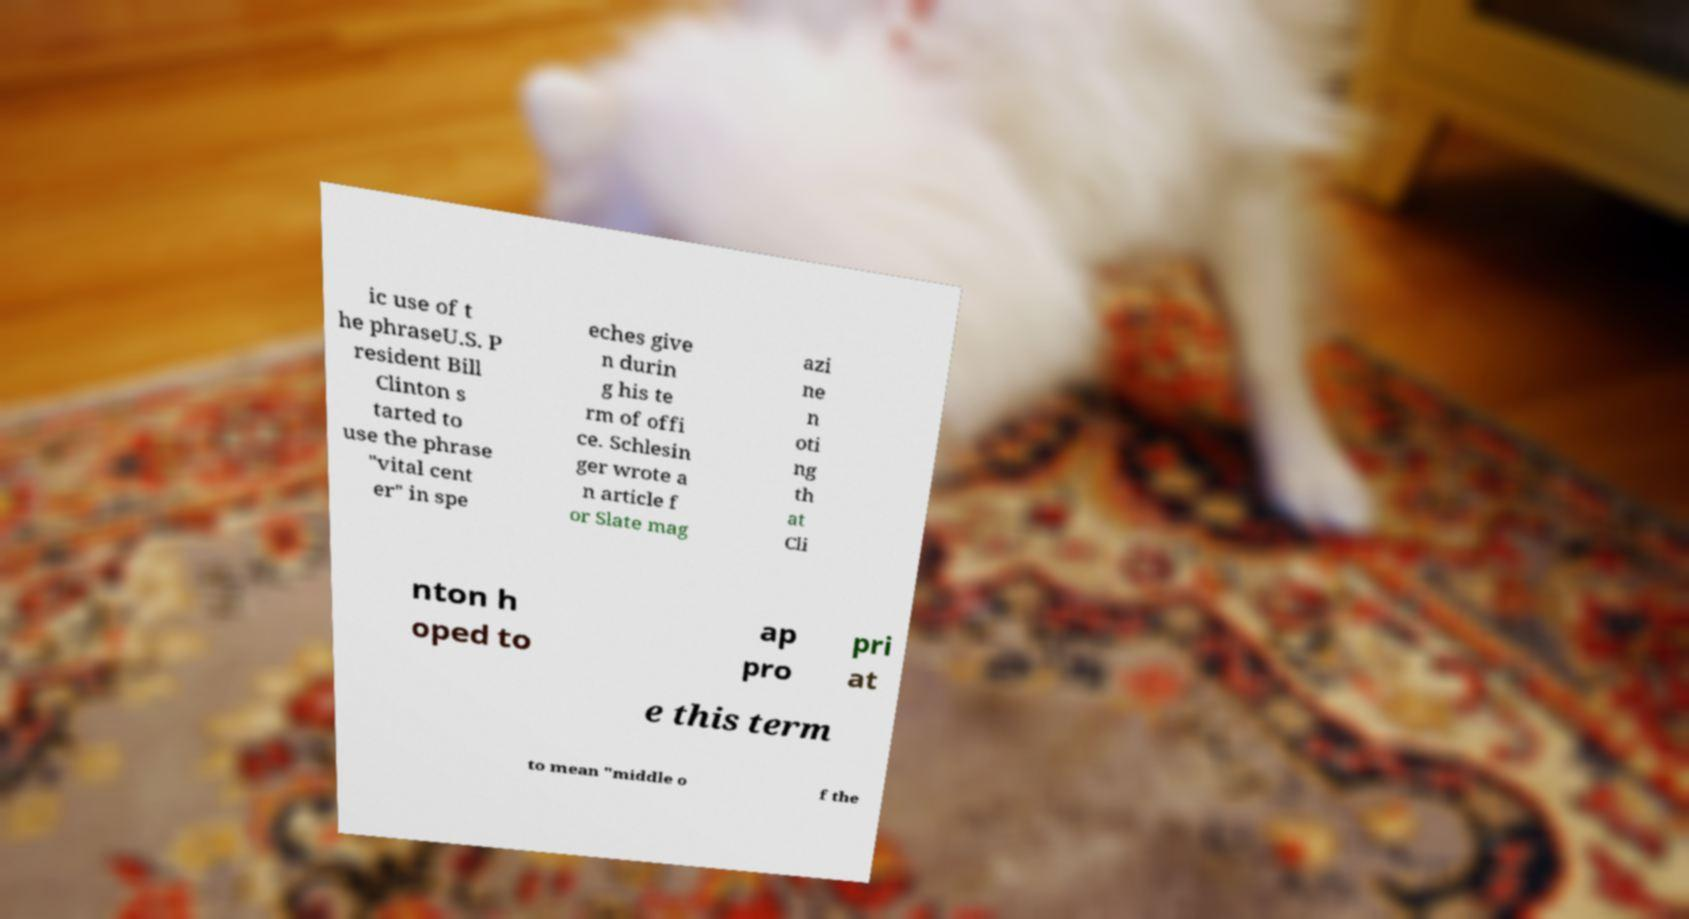Please read and relay the text visible in this image. What does it say? ic use of t he phraseU.S. P resident Bill Clinton s tarted to use the phrase "vital cent er" in spe eches give n durin g his te rm of offi ce. Schlesin ger wrote a n article f or Slate mag azi ne n oti ng th at Cli nton h oped to ap pro pri at e this term to mean "middle o f the 